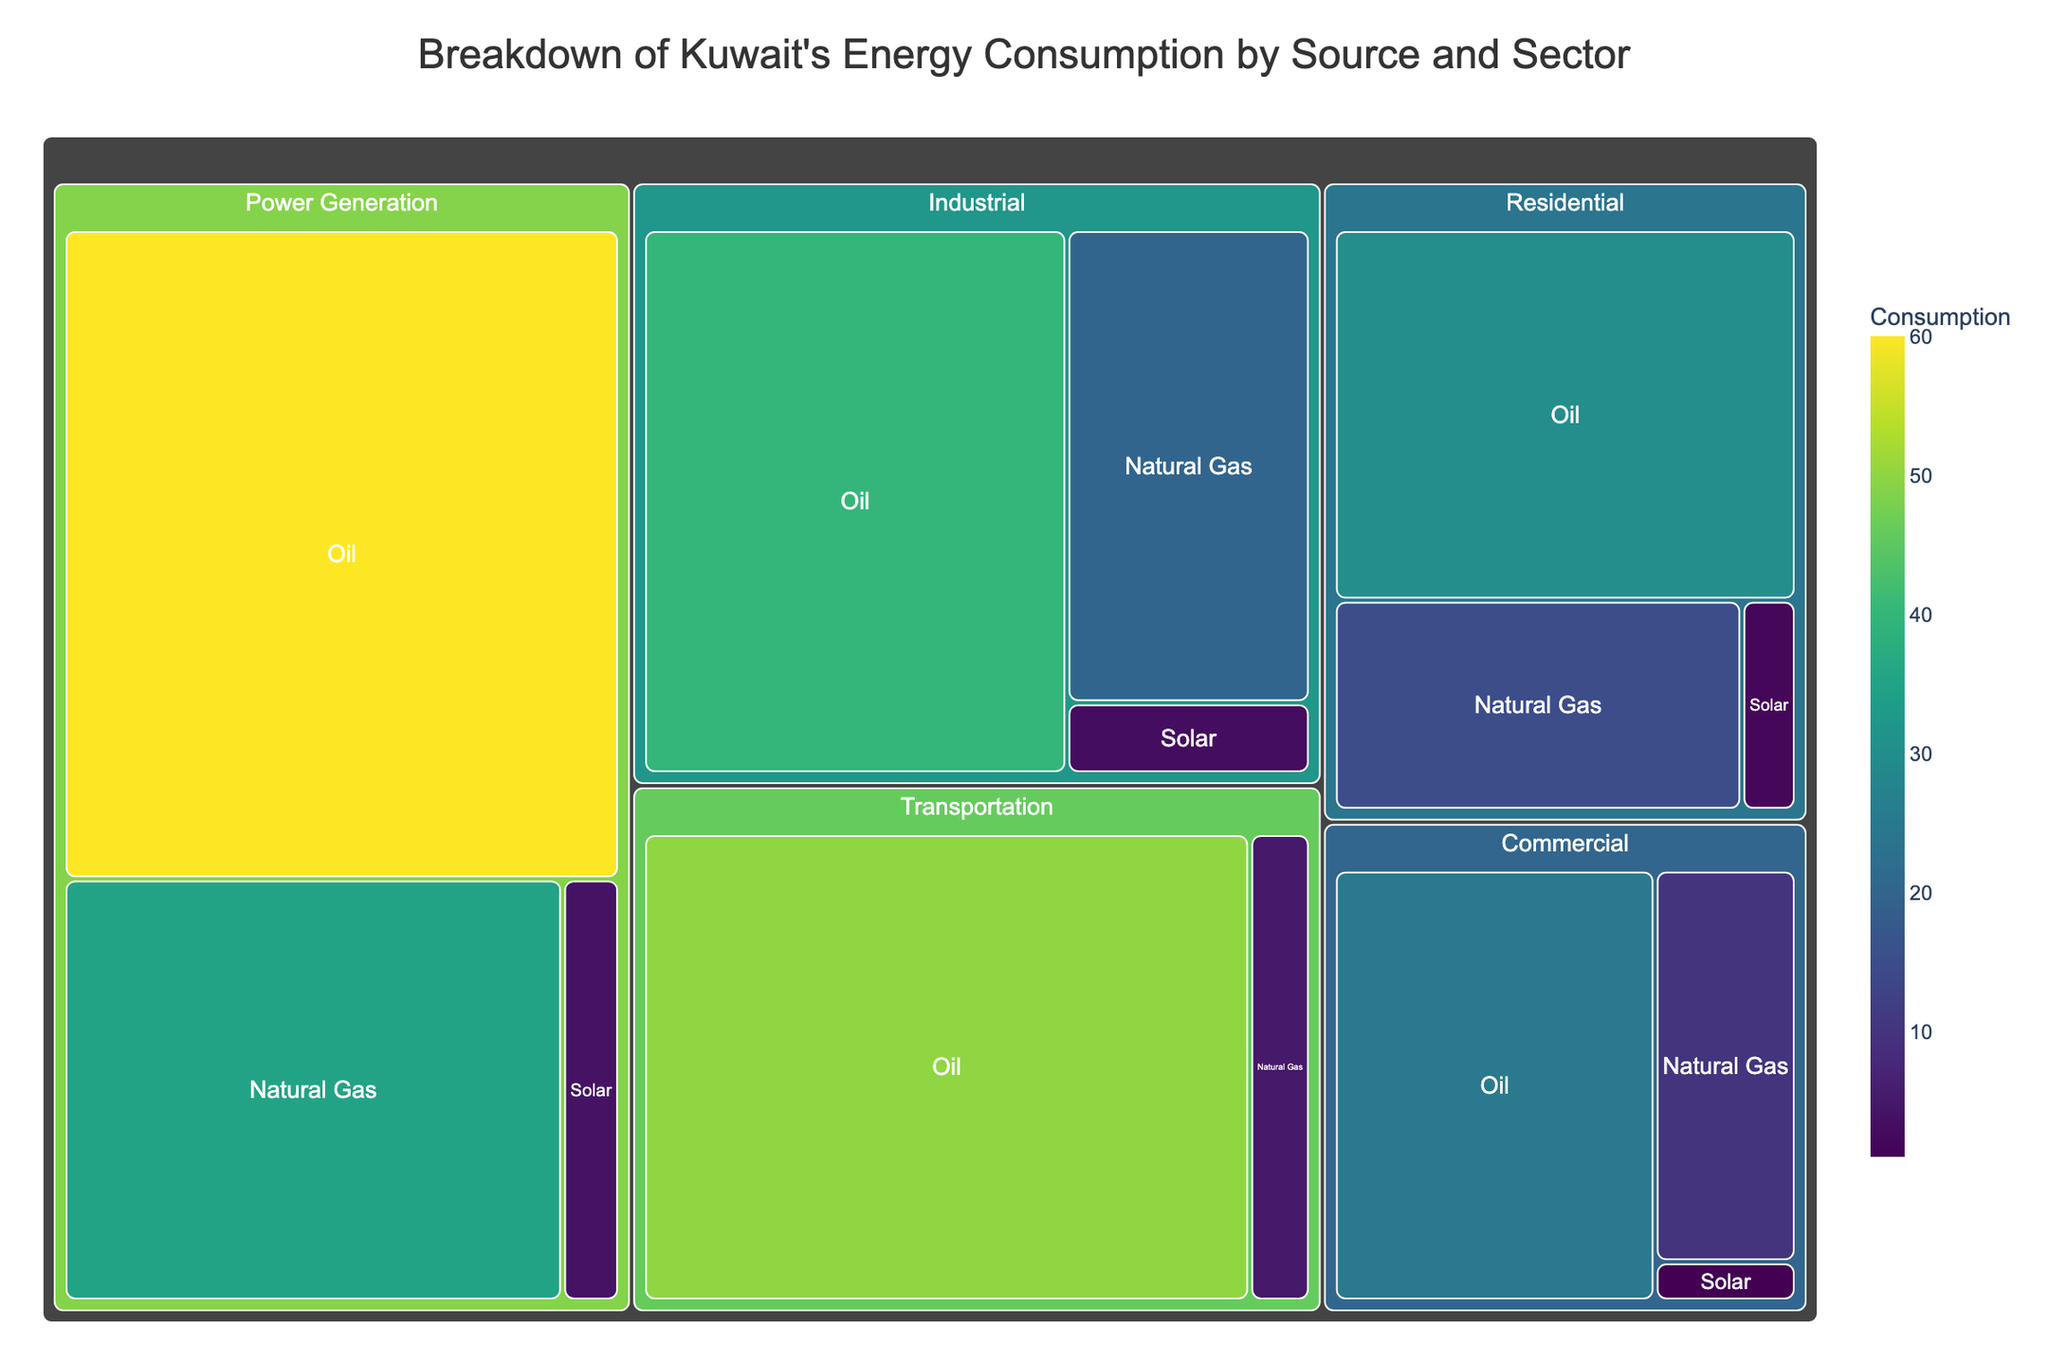What is the title of the treemap? The title is displayed at the top of the treemap, typically in a larger font and central position.
Answer: Breakdown of Kuwait's Energy Consumption by Source and Sector Which sector has the highest energy consumption? Locate the largest segment in the treemap, as size represents consumption.
Answer: Power Generation Which energy source is least used in the Residential sector? Look for the smallest segment within the Residential sector since it represents the least usage.
Answer: Solar What is the total energy consumption of the Commercial sector? Sum the values of all sources (Oil, Natural Gas, Solar) in the Commercial sector: 25 + 10 + 1 = 36.
Answer: 36 How does the transportation sector's consumption of oil compare to that of natural gas? Compare the size of the segments within the Transportation sector for Oil (50) and Natural Gas (5).
Answer: Oil is significantly higher than Natural Gas Which sector uses the most Natural Gas? Find the largest segment representing Natural Gas within the sectors.
Answer: Power Generation Is the consumption of Solar energy greater in the Industrial or Residential sector? Compare the Solar segment sizes in the Industrial (3) and Residential (2) sectors.
Answer: Industrial uses more Solar energy than Residential If you add up the Oil consumption in Residential and Commercial sectors, how much is it? Sum the Oil values: 30 (Residential) + 25 (Commercial) = 55.
Answer: 55 Which sector predominantly relies on a single energy source, and what is that source? Look for sectors with one segment significantly larger than others.
Answer: Transportation, Oil 